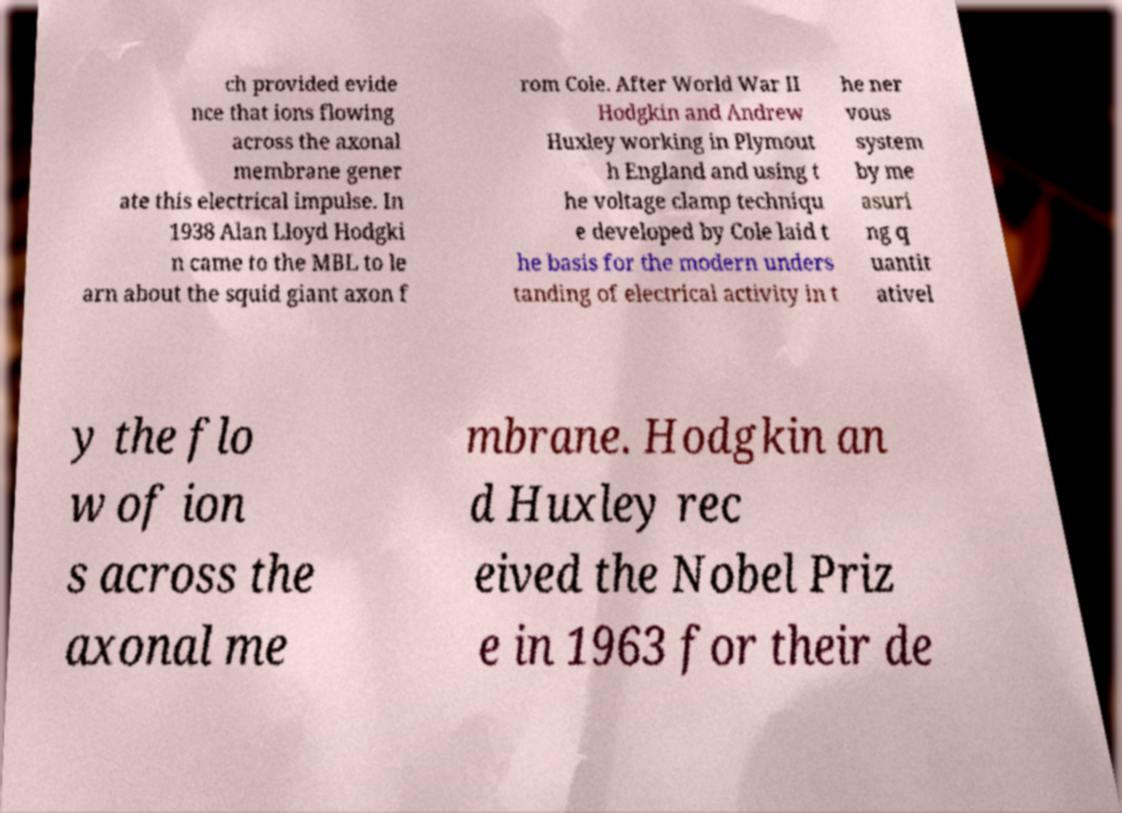Could you assist in decoding the text presented in this image and type it out clearly? ch provided evide nce that ions flowing across the axonal membrane gener ate this electrical impulse. In 1938 Alan Lloyd Hodgki n came to the MBL to le arn about the squid giant axon f rom Cole. After World War II Hodgkin and Andrew Huxley working in Plymout h England and using t he voltage clamp techniqu e developed by Cole laid t he basis for the modern unders tanding of electrical activity in t he ner vous system by me asuri ng q uantit ativel y the flo w of ion s across the axonal me mbrane. Hodgkin an d Huxley rec eived the Nobel Priz e in 1963 for their de 